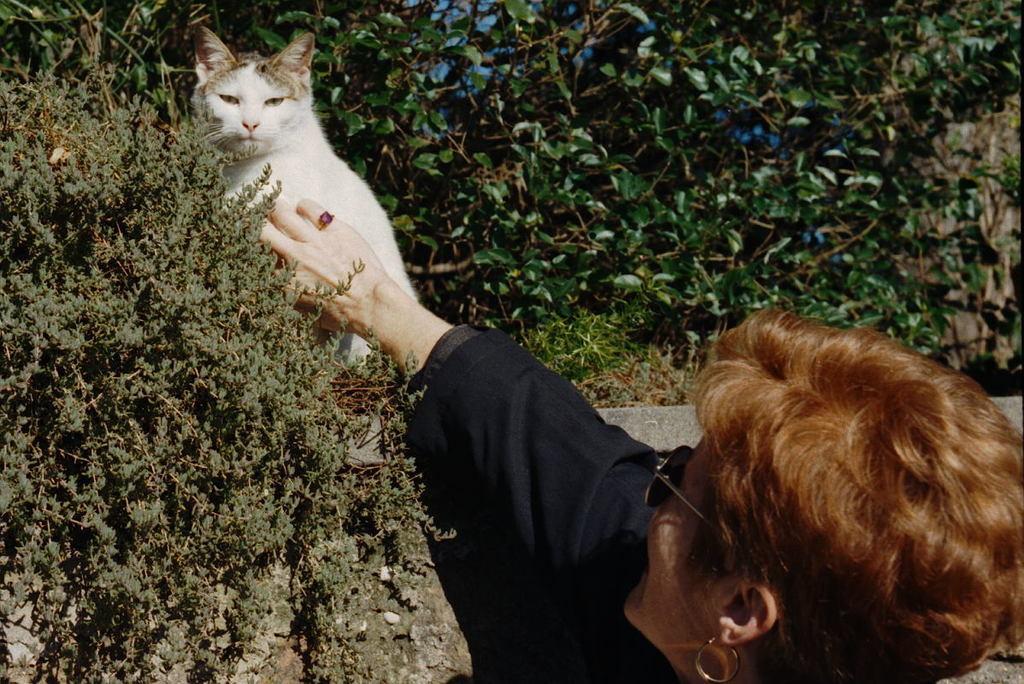Could you give a brief overview of what you see in this image? This is a white cat sitting on the wall. Here is the women wearing black dress,goggles and ear rings. She is touching the cat. This is a small plant. At background I can see trees. 